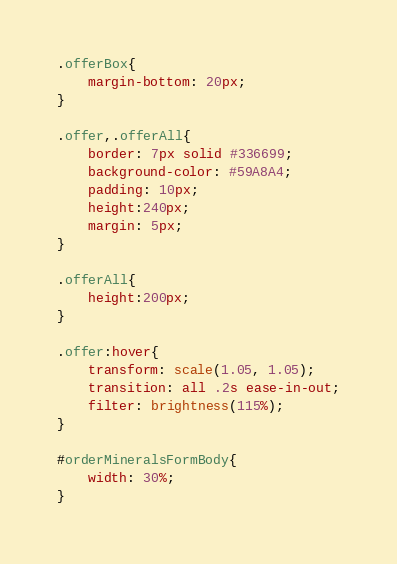<code> <loc_0><loc_0><loc_500><loc_500><_CSS_>.offerBox{
	margin-bottom: 20px;
}

.offer,.offerAll{
	border: 7px solid #336699;
	background-color: #59A8A4;
	padding: 10px;
	height:240px;
	margin: 5px;
}

.offerAll{
    height:200px;
}

.offer:hover{
	transform: scale(1.05, 1.05);
	transition: all .2s ease-in-out;
	filter: brightness(115%);
}

#orderMineralsFormBody{
	width: 30%;
}
</code> 